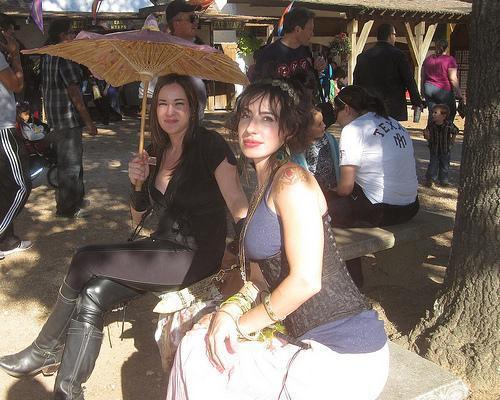How many umbrellas are in the picture?
Give a very brief answer. 1. How many women are facing the camera?
Give a very brief answer. 2. 